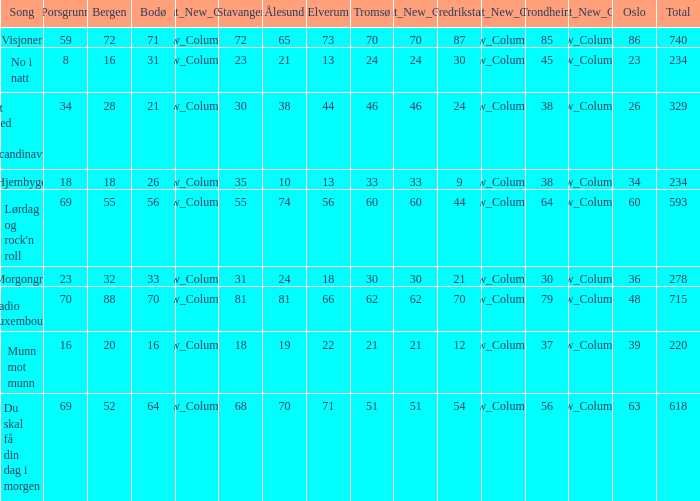How many elverum are tehre for et sted i scandinavia? 1.0. 